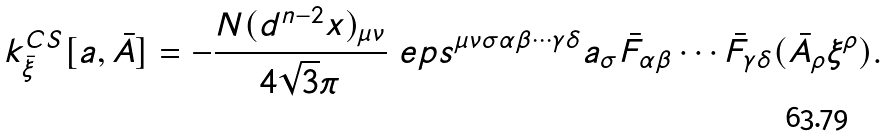<formula> <loc_0><loc_0><loc_500><loc_500>k ^ { C S } _ { \bar { \xi } } [ a , \bar { A } ] = - \frac { N ( d ^ { n - 2 } x ) _ { \mu \nu } } { 4 \sqrt { 3 } \pi } \ e p s ^ { \mu \nu \sigma \alpha \beta \cdots \gamma \delta } a _ { \sigma } \bar { F } _ { \alpha \beta } \cdots \bar { F } _ { \gamma \delta } ( \bar { A } _ { \rho } \xi ^ { \rho } ) .</formula> 